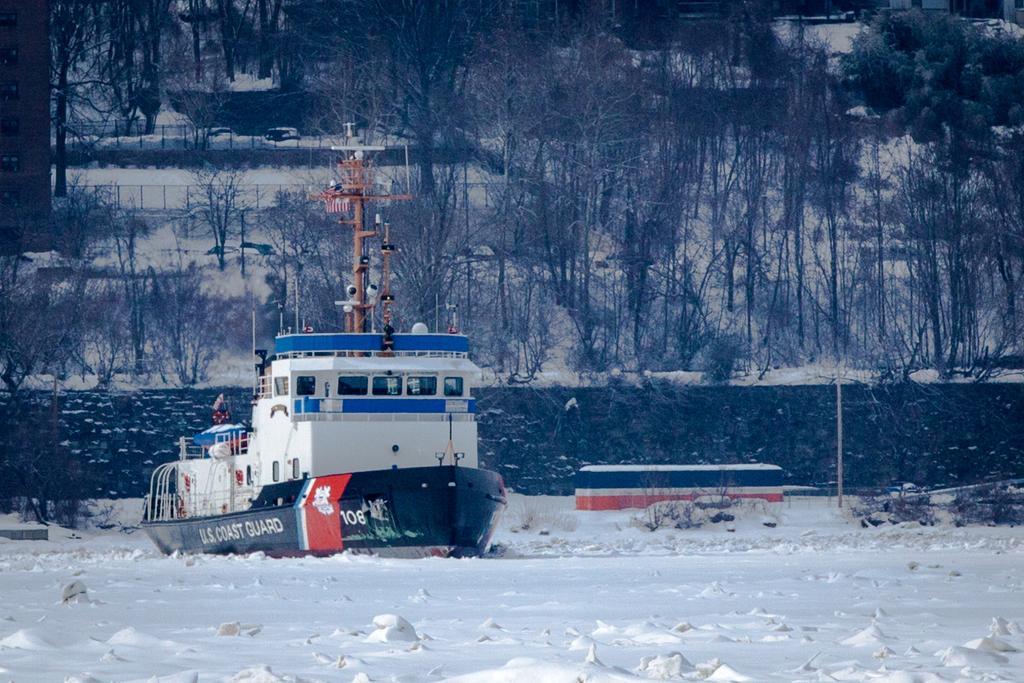In one or two sentences, can you explain what this image depicts? In the image we can see the boat, here we can see wall, pole, trees and the fence. Everywhere there is snow, white in color. 